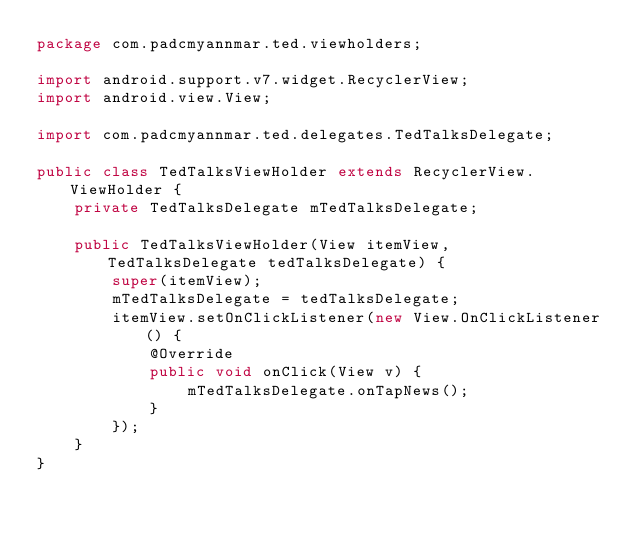<code> <loc_0><loc_0><loc_500><loc_500><_Java_>package com.padcmyannmar.ted.viewholders;

import android.support.v7.widget.RecyclerView;
import android.view.View;

import com.padcmyannmar.ted.delegates.TedTalksDelegate;

public class TedTalksViewHolder extends RecyclerView.ViewHolder {
    private TedTalksDelegate mTedTalksDelegate;

    public TedTalksViewHolder(View itemView, TedTalksDelegate tedTalksDelegate) {
        super(itemView);
        mTedTalksDelegate = tedTalksDelegate;
        itemView.setOnClickListener(new View.OnClickListener() {
            @Override
            public void onClick(View v) {
                mTedTalksDelegate.onTapNews();
            }
        });
    }
}
</code> 